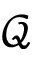<formula> <loc_0><loc_0><loc_500><loc_500>\mathcal { Q }</formula> 